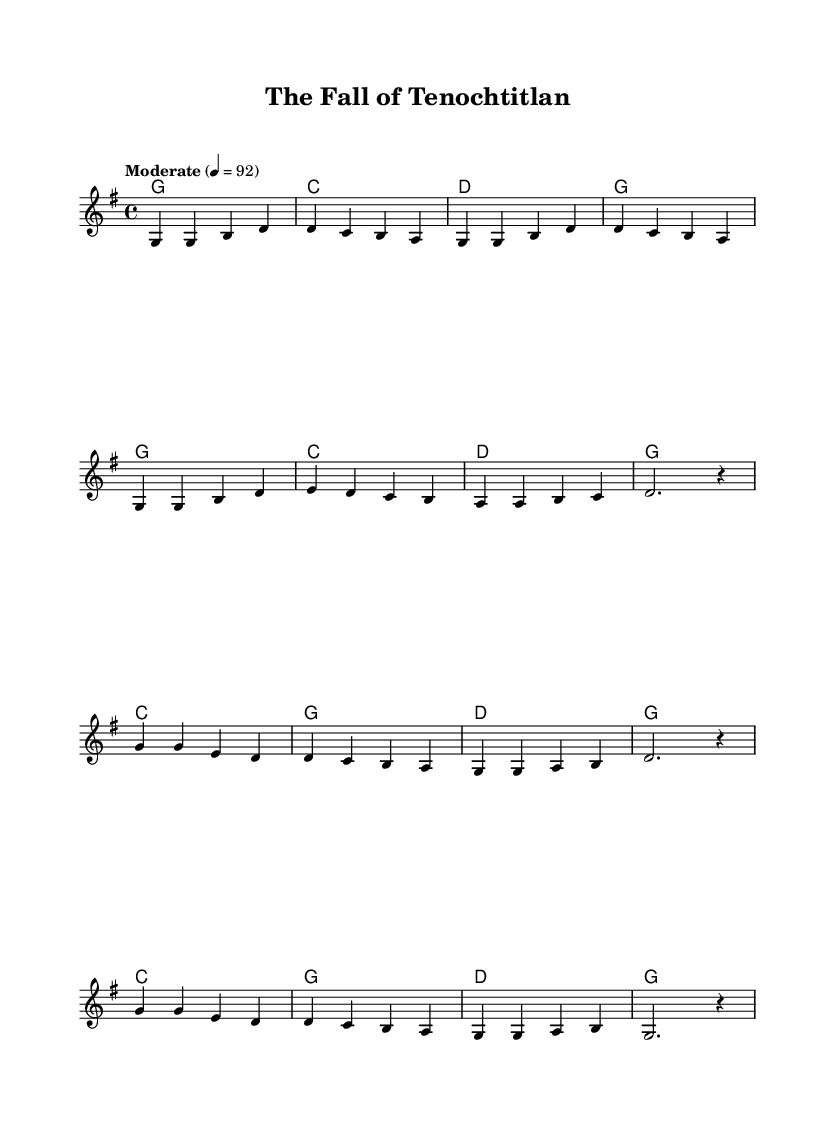What is the key signature of this music? The key signature indicates that the piece is in G major, which has one sharp (F#).
Answer: G major What is the time signature of this music? The time signature is represented at the beginning of the piece, indicating that it is in 4/4 time, which means there are four beats in each measure.
Answer: 4/4 What is the tempo marking for this piece? The tempo marking is found at the beginning of the score, showing "Moderate" with a beats-per-minute indication of 92.
Answer: Moderate 4 = 92 How many verses are included in this song? By counting the sections labeled in the score, we see there are two verses: the first verse, followed by the chorus, and the same pattern repeats.
Answer: 2 What historical event does this ballad recount? The lyrics specifically reference the fall of the Aztec Empire in the year 1519, which was notably a significant historical event linked to Spanish conquest.
Answer: The Fall of Tenochtitlan Which two chords are repeatedly used in the verses? The chord progression in the verse consists of G and C, which appear prominently as indicated in the chord mode section.
Answer: G and C What is the last word of the chorus? The last word of the chorus lines is "extend", which is the conclusion to the historical reference made in the lyrics.
Answer: extend 